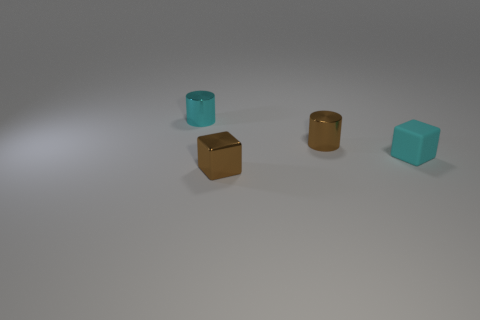Add 1 big blue balls. How many objects exist? 5 Add 4 large metal cubes. How many large metal cubes exist? 4 Subtract 0 green blocks. How many objects are left? 4 Subtract 1 cubes. How many cubes are left? 1 Subtract all purple cylinders. Subtract all brown cubes. How many cylinders are left? 2 Subtract all shiny cylinders. Subtract all matte objects. How many objects are left? 1 Add 1 tiny metal cylinders. How many tiny metal cylinders are left? 3 